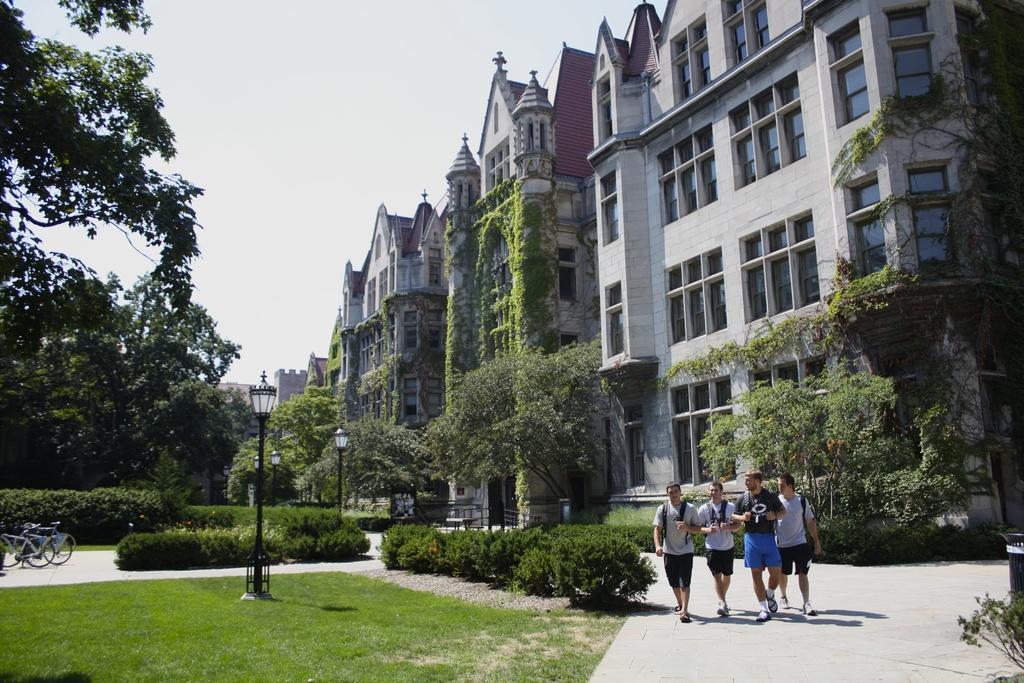Please provide a concise description of this image. This image is clicked outside. There are four persons walking. At the bottom, there is green grass and road. In the background, there are many many buildings. To the left, there are trees and bicycles parked. 